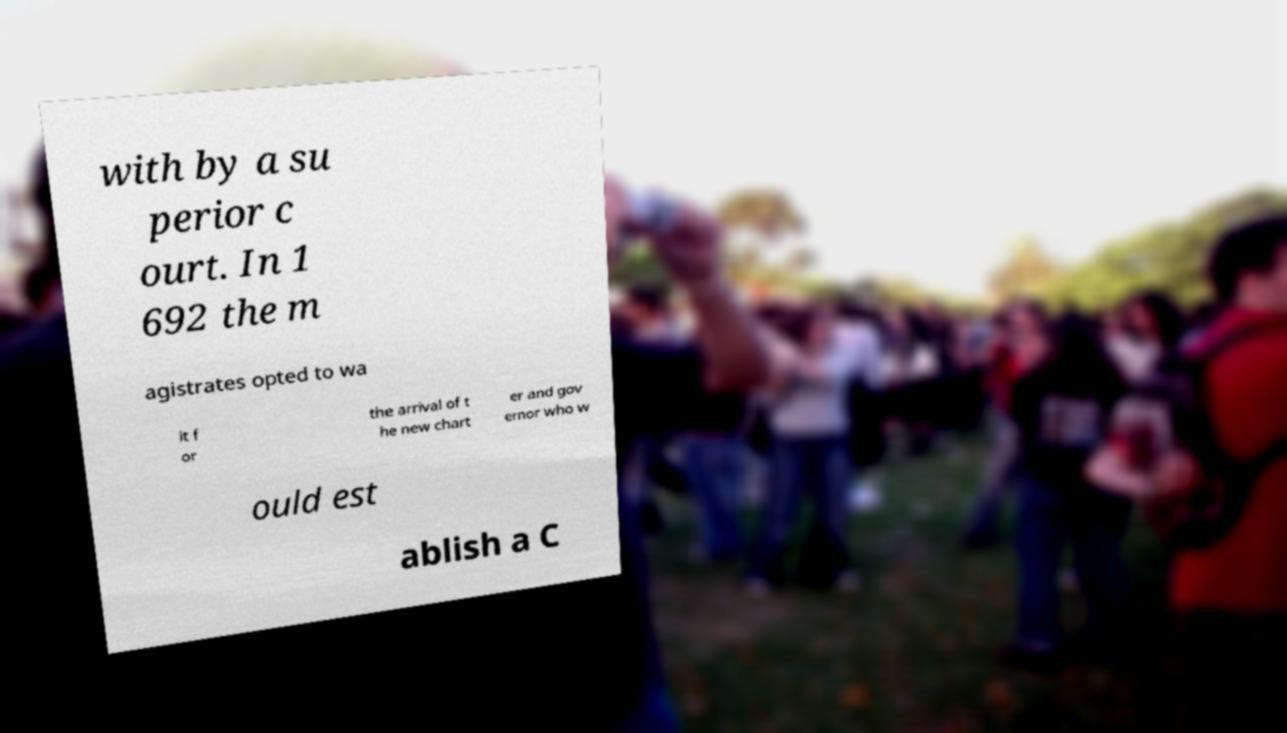Can you accurately transcribe the text from the provided image for me? with by a su perior c ourt. In 1 692 the m agistrates opted to wa it f or the arrival of t he new chart er and gov ernor who w ould est ablish a C 